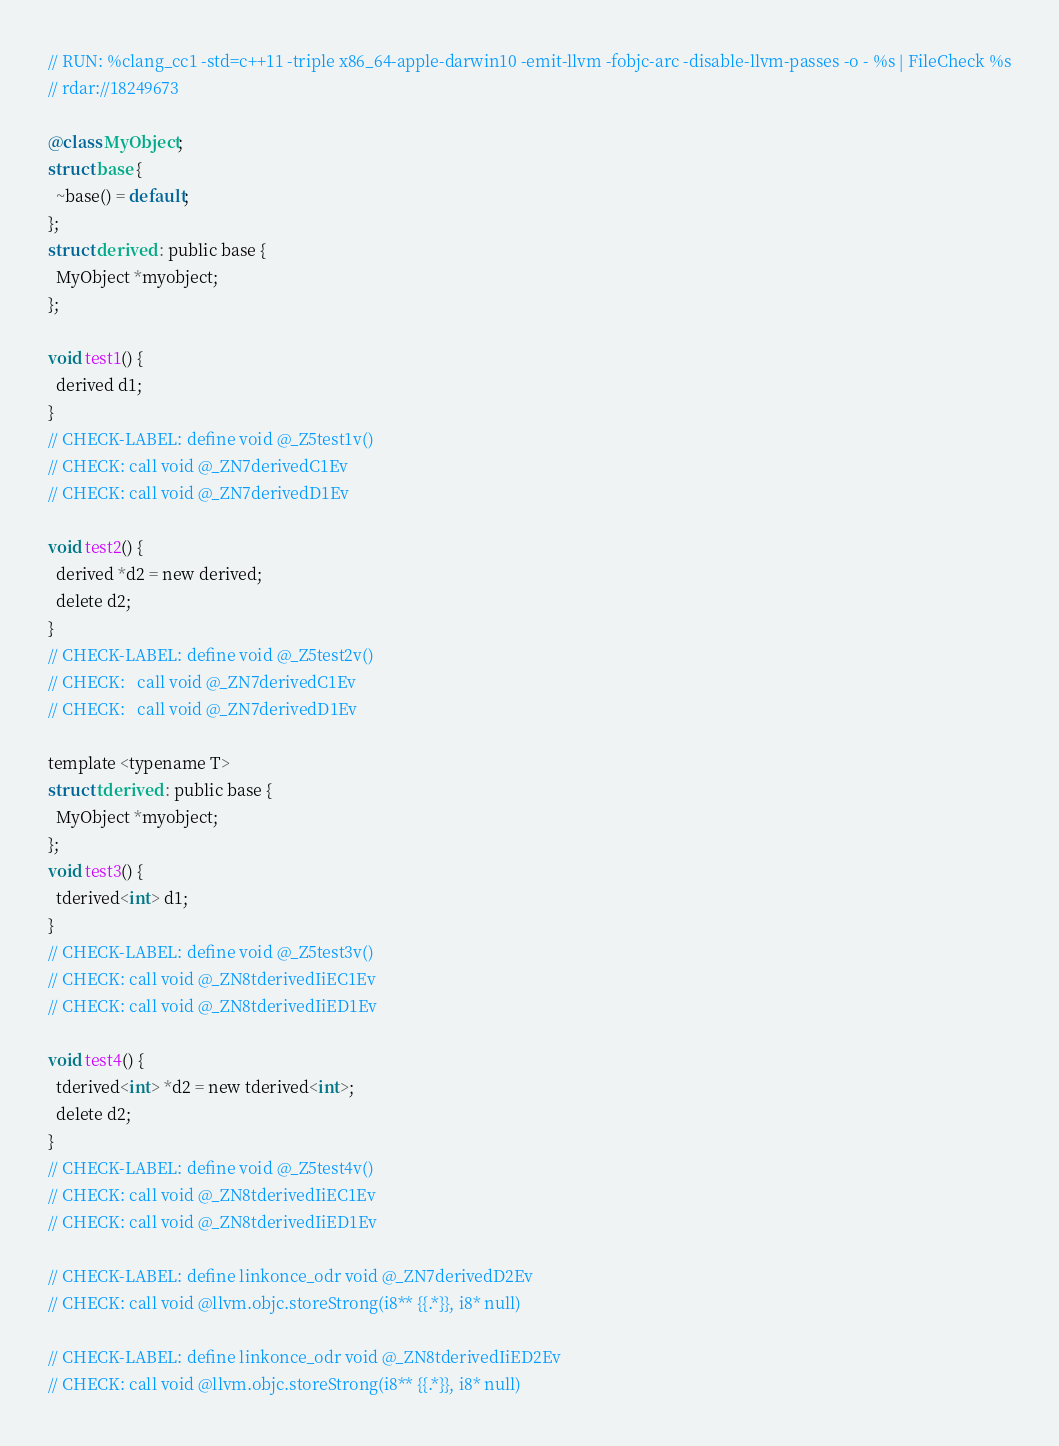Convert code to text. <code><loc_0><loc_0><loc_500><loc_500><_ObjectiveC_>// RUN: %clang_cc1 -std=c++11 -triple x86_64-apple-darwin10 -emit-llvm -fobjc-arc -disable-llvm-passes -o - %s | FileCheck %s
// rdar://18249673

@class MyObject;
struct base {
  ~base() = default;
};
struct derived : public base {
  MyObject *myobject;
};

void test1() {
  derived d1;
}
// CHECK-LABEL: define void @_Z5test1v()
// CHECK: call void @_ZN7derivedC1Ev
// CHECK: call void @_ZN7derivedD1Ev

void test2() {
  derived *d2 = new derived;
  delete d2;
}
// CHECK-LABEL: define void @_Z5test2v()
// CHECK:   call void @_ZN7derivedC1Ev
// CHECK:   call void @_ZN7derivedD1Ev

template <typename T>
struct tderived : public base {
  MyObject *myobject;
};
void test3() {
  tderived<int> d1;
}
// CHECK-LABEL: define void @_Z5test3v()
// CHECK: call void @_ZN8tderivedIiEC1Ev
// CHECK: call void @_ZN8tderivedIiED1Ev

void test4() {
  tderived<int> *d2 = new tderived<int>;
  delete d2;
}
// CHECK-LABEL: define void @_Z5test4v()
// CHECK: call void @_ZN8tderivedIiEC1Ev
// CHECK: call void @_ZN8tderivedIiED1Ev

// CHECK-LABEL: define linkonce_odr void @_ZN7derivedD2Ev
// CHECK: call void @llvm.objc.storeStrong(i8** {{.*}}, i8* null)

// CHECK-LABEL: define linkonce_odr void @_ZN8tderivedIiED2Ev
// CHECK: call void @llvm.objc.storeStrong(i8** {{.*}}, i8* null)
</code> 